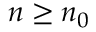Convert formula to latex. <formula><loc_0><loc_0><loc_500><loc_500>n \geq n _ { 0 }</formula> 